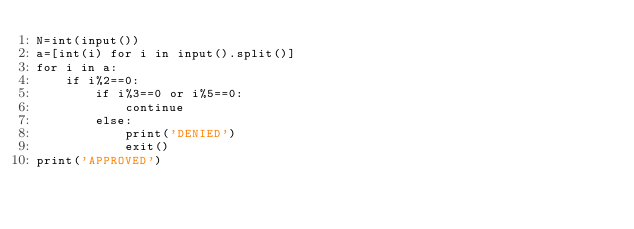Convert code to text. <code><loc_0><loc_0><loc_500><loc_500><_Python_>N=int(input())
a=[int(i) for i in input().split()]
for i in a:
    if i%2==0:
        if i%3==0 or i%5==0:
            continue
        else:
            print('DENIED')
            exit()
print('APPROVED')</code> 